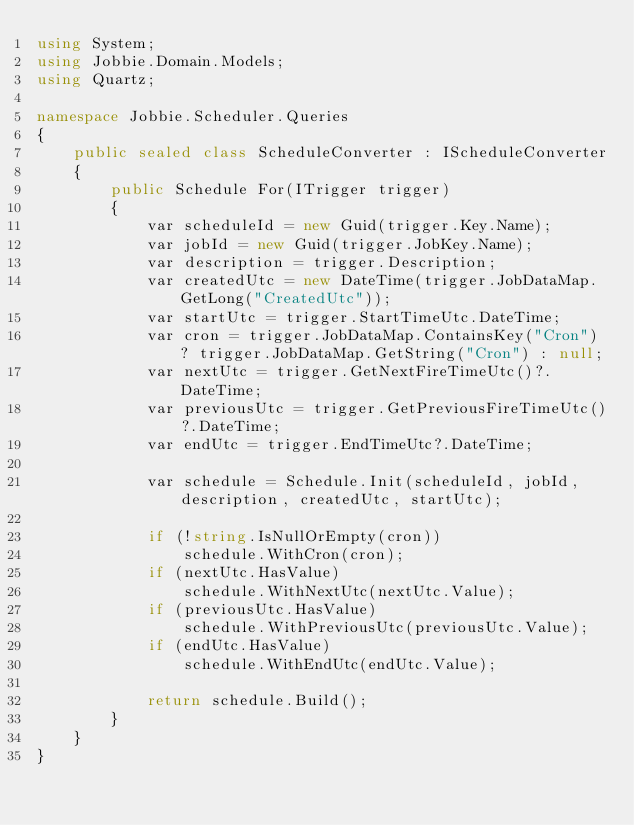<code> <loc_0><loc_0><loc_500><loc_500><_C#_>using System;
using Jobbie.Domain.Models;
using Quartz;

namespace Jobbie.Scheduler.Queries
{
    public sealed class ScheduleConverter : IScheduleConverter
    {
        public Schedule For(ITrigger trigger)
        {
            var scheduleId = new Guid(trigger.Key.Name);
            var jobId = new Guid(trigger.JobKey.Name);
            var description = trigger.Description;
            var createdUtc = new DateTime(trigger.JobDataMap.GetLong("CreatedUtc"));
            var startUtc = trigger.StartTimeUtc.DateTime;
            var cron = trigger.JobDataMap.ContainsKey("Cron") ? trigger.JobDataMap.GetString("Cron") : null;
            var nextUtc = trigger.GetNextFireTimeUtc()?.DateTime;
            var previousUtc = trigger.GetPreviousFireTimeUtc()?.DateTime;
            var endUtc = trigger.EndTimeUtc?.DateTime;

            var schedule = Schedule.Init(scheduleId, jobId, description, createdUtc, startUtc);

            if (!string.IsNullOrEmpty(cron))
                schedule.WithCron(cron);
            if (nextUtc.HasValue)
                schedule.WithNextUtc(nextUtc.Value);
            if (previousUtc.HasValue)
                schedule.WithPreviousUtc(previousUtc.Value);
            if (endUtc.HasValue)
                schedule.WithEndUtc(endUtc.Value);

            return schedule.Build();
        }
    }
}</code> 